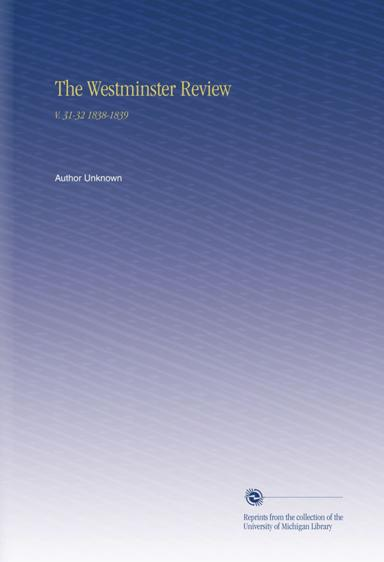What type of articles might I find in this volume of 'The Westminster Review'? In volumes 31 and 32 of 'The Westminster Review,' you might find a diverse array of articles ranging from detailed critiques of governmental policies to philosophical essays on utilitarianism, reviews of scientific discoveries, and analyses of literature. The publication aimed to disseminate knowledge and spark intellectual discourse among educated readers, addressing pressing issues of the time and providing insights into the evolving cultural landscape. 